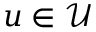Convert formula to latex. <formula><loc_0><loc_0><loc_500><loc_500>u \in \mathcal { U }</formula> 